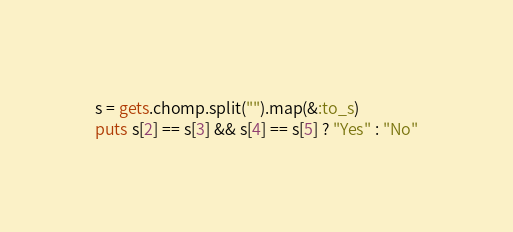<code> <loc_0><loc_0><loc_500><loc_500><_Ruby_>s = gets.chomp.split("").map(&:to_s)
puts s[2] == s[3] && s[4] == s[5] ? "Yes" : "No"</code> 